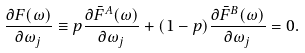Convert formula to latex. <formula><loc_0><loc_0><loc_500><loc_500>\frac { \partial { F } ( \omega ) } { \partial \omega _ { j } } \equiv p \frac { \partial \bar { F } ^ { A } ( \omega ) } { \partial \omega _ { j } } + ( 1 - p ) \frac { \partial \bar { F } ^ { B } ( \omega ) } { \partial \omega _ { j } } = 0 .</formula> 